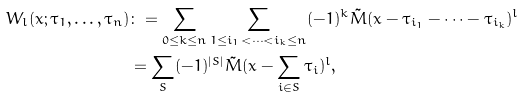<formula> <loc_0><loc_0><loc_500><loc_500>W _ { l } ( x ; \tau _ { 1 } , \dots , \tau _ { n } ) & \colon = \sum _ { 0 \leq k \leq n } \sum _ { 1 \leq i _ { 1 } < \dots < i _ { k } \leq n } ( - 1 ) ^ { k } \tilde { M } ( x - \tau _ { i _ { 1 } } - \dots - \tau _ { i _ { k } } ) ^ { l } \\ & = \sum _ { S } ( - 1 ) ^ { | S | } \tilde { M } ( x - \sum _ { i \in S } \tau _ { i } ) ^ { l } ,</formula> 